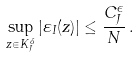<formula> <loc_0><loc_0><loc_500><loc_500>\sup _ { z \in K _ { J } ^ { \delta } } | \varepsilon _ { I } ( z ) | \leq \frac { C _ { J } ^ { \epsilon } } { N } \, .</formula> 